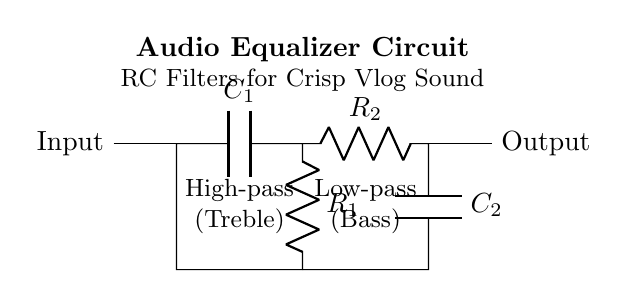What is the function of capacitor C1 in this circuit? Capacitor C1 is used as a high-pass filter component, allowing high frequencies (treble) to pass while blocking low frequencies. This is indicated by its placement before resistor R1 in the circuit diagram.
Answer: High-pass filter What does resistor R2 do in this circuit? Resistor R2 is part of a low-pass filter alongside capacitor C2, allowing low frequencies (bass) to pass while attenuating higher frequencies. Its position after C2 confirms its filtering role.
Answer: Low-pass filter What is the role of capacitors in an audio equalizer circuit? Capacitors in an audio equalizer circuit control the frequency response by creating filters that allow certain frequency ranges to pass while blocking others, thus shaping the tone of the audio signal.
Answer: Frequency response How many filters are present in the circuit? The circuit diagram shows two filters: a high-pass filter and a low-pass filter. They are designed to enhance treble and bass sounds, respectively, contributing to the overall audio quality.
Answer: Two filters What are the components used for the high-pass filter? The high-pass filter comprises capacitor C1 and resistor R1, with C1 connected in series before R1, allowing high frequencies to be filtered through.
Answer: Capacitor C1 and resistor R1 Which component is associated with treble adjustment? Capacitor C1 is associated with treble adjustment as it forms the high-pass filter that allows treble frequencies to pass through effectively in the audio equalizer circuit.
Answer: Capacitor C1 